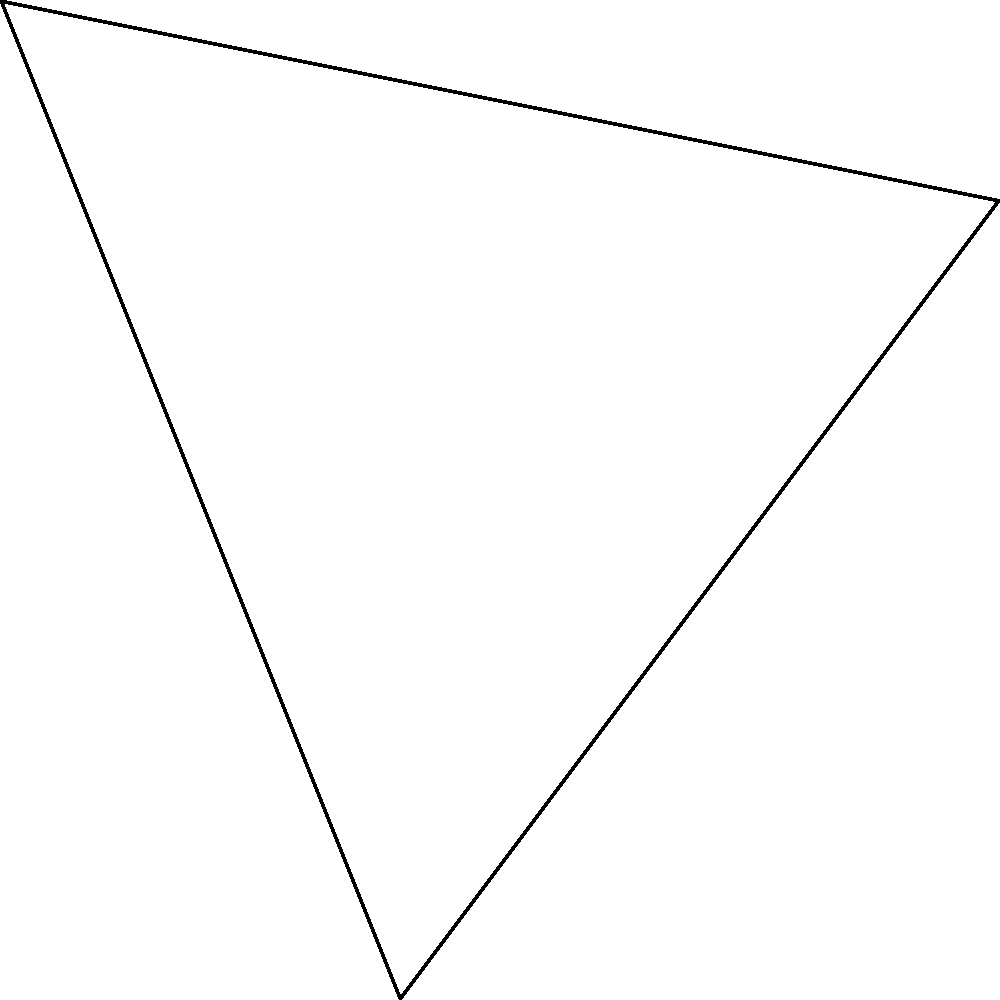In the vast expanse of the Andromeda Nebula, two intergalactic spaceships, A and B, are approaching a state-of-the-art cylindrical space station. From the station's perspective, Ship A is located at coordinates (3, 4) and Ship B at (-2, 5) in the station's reference frame. What is the measure of the angle $\theta$ formed by the two spaceships with respect to the space station's center? To find the angle $\theta$, we'll use the following steps:

1) First, we need to calculate the vectors from the space station (origin) to each ship:
   Vector OA = (3, 4)
   Vector OB = (-2, 5)

2) The angle between these vectors can be found using the dot product formula:
   $\cos \theta = \frac{\vec{OA} \cdot \vec{OB}}{|\vec{OA}| |\vec{OB}|}$

3) Calculate the dot product $\vec{OA} \cdot \vec{OB}$:
   $\vec{OA} \cdot \vec{OB} = (3)(-2) + (4)(5) = -6 + 20 = 14$

4) Calculate the magnitudes of the vectors:
   $|\vec{OA}| = \sqrt{3^2 + 4^2} = \sqrt{25} = 5$
   $|\vec{OB}| = \sqrt{(-2)^2 + 5^2} = \sqrt{29}$

5) Substitute into the formula:
   $\cos \theta = \frac{14}{5\sqrt{29}}$

6) Take the inverse cosine (arccos) of both sides:
   $\theta = \arccos(\frac{14}{5\sqrt{29}})$

7) Calculate the result:
   $\theta \approx 1.249$ radians or $71.57$ degrees
Answer: $71.57°$ 